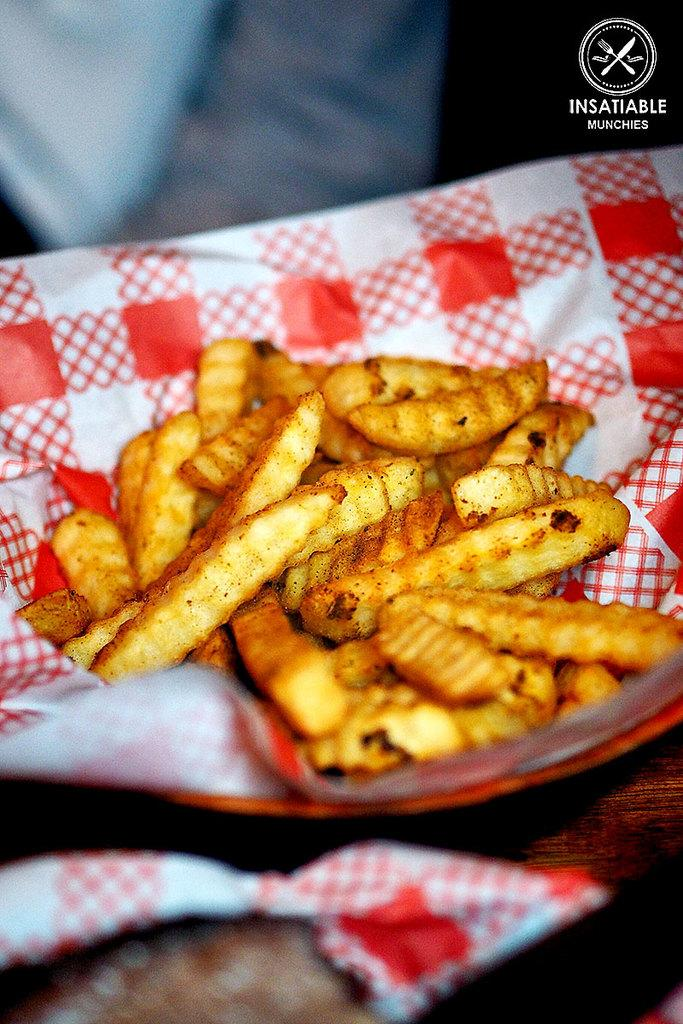What type of food can be seen in the image? There are fries in the image. How are the fries arranged or presented? The fries are in a plate. Is there anything separating the fries from the plate? Yes, there is a paper between the fries and the plate. What colors can be seen on the paper? The paper is white and red in color. What type of dirt can be seen on the ghost in the image? There is no ghost present in the image, and therefore no dirt can be seen on it. 